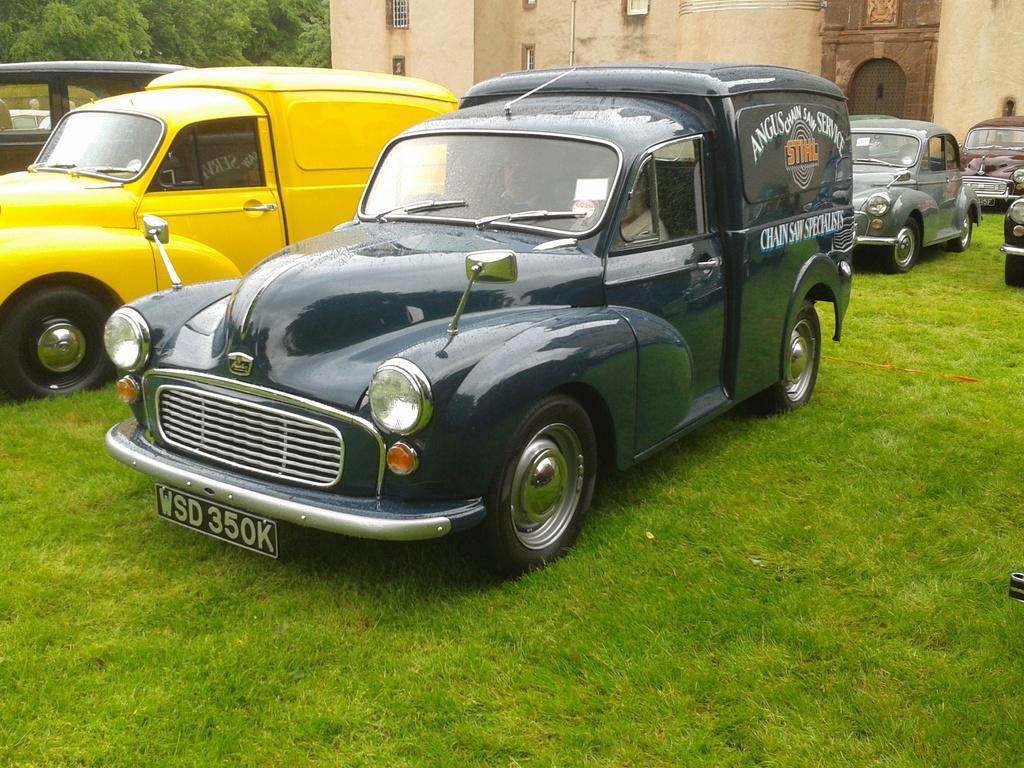Could you give a brief overview of what you see in this image? In this image I can see the vehicles are on the grass. The vehicles are in different colors. In the background I can see the building with windows and many trees. 